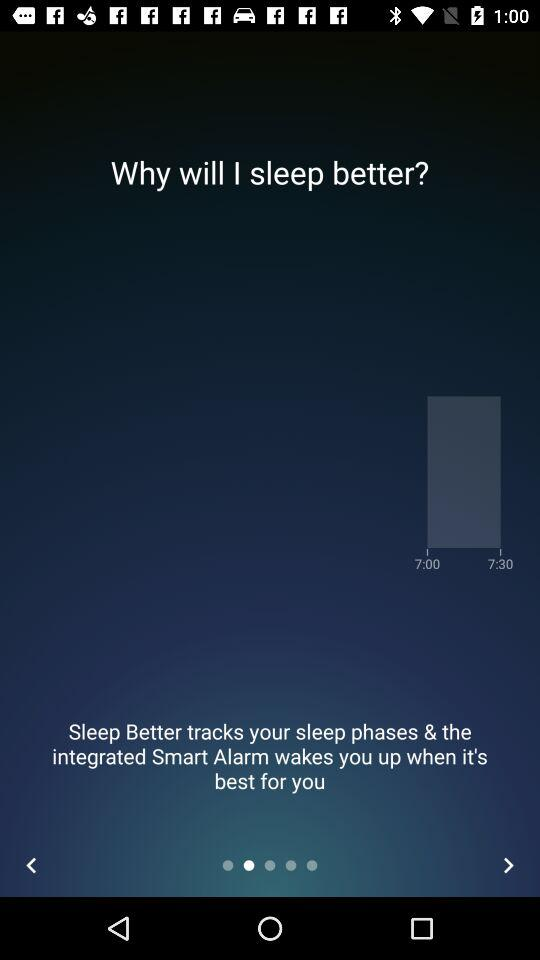What is the difference in time between the two alarm times?
Answer the question using a single word or phrase. 30 minutes 